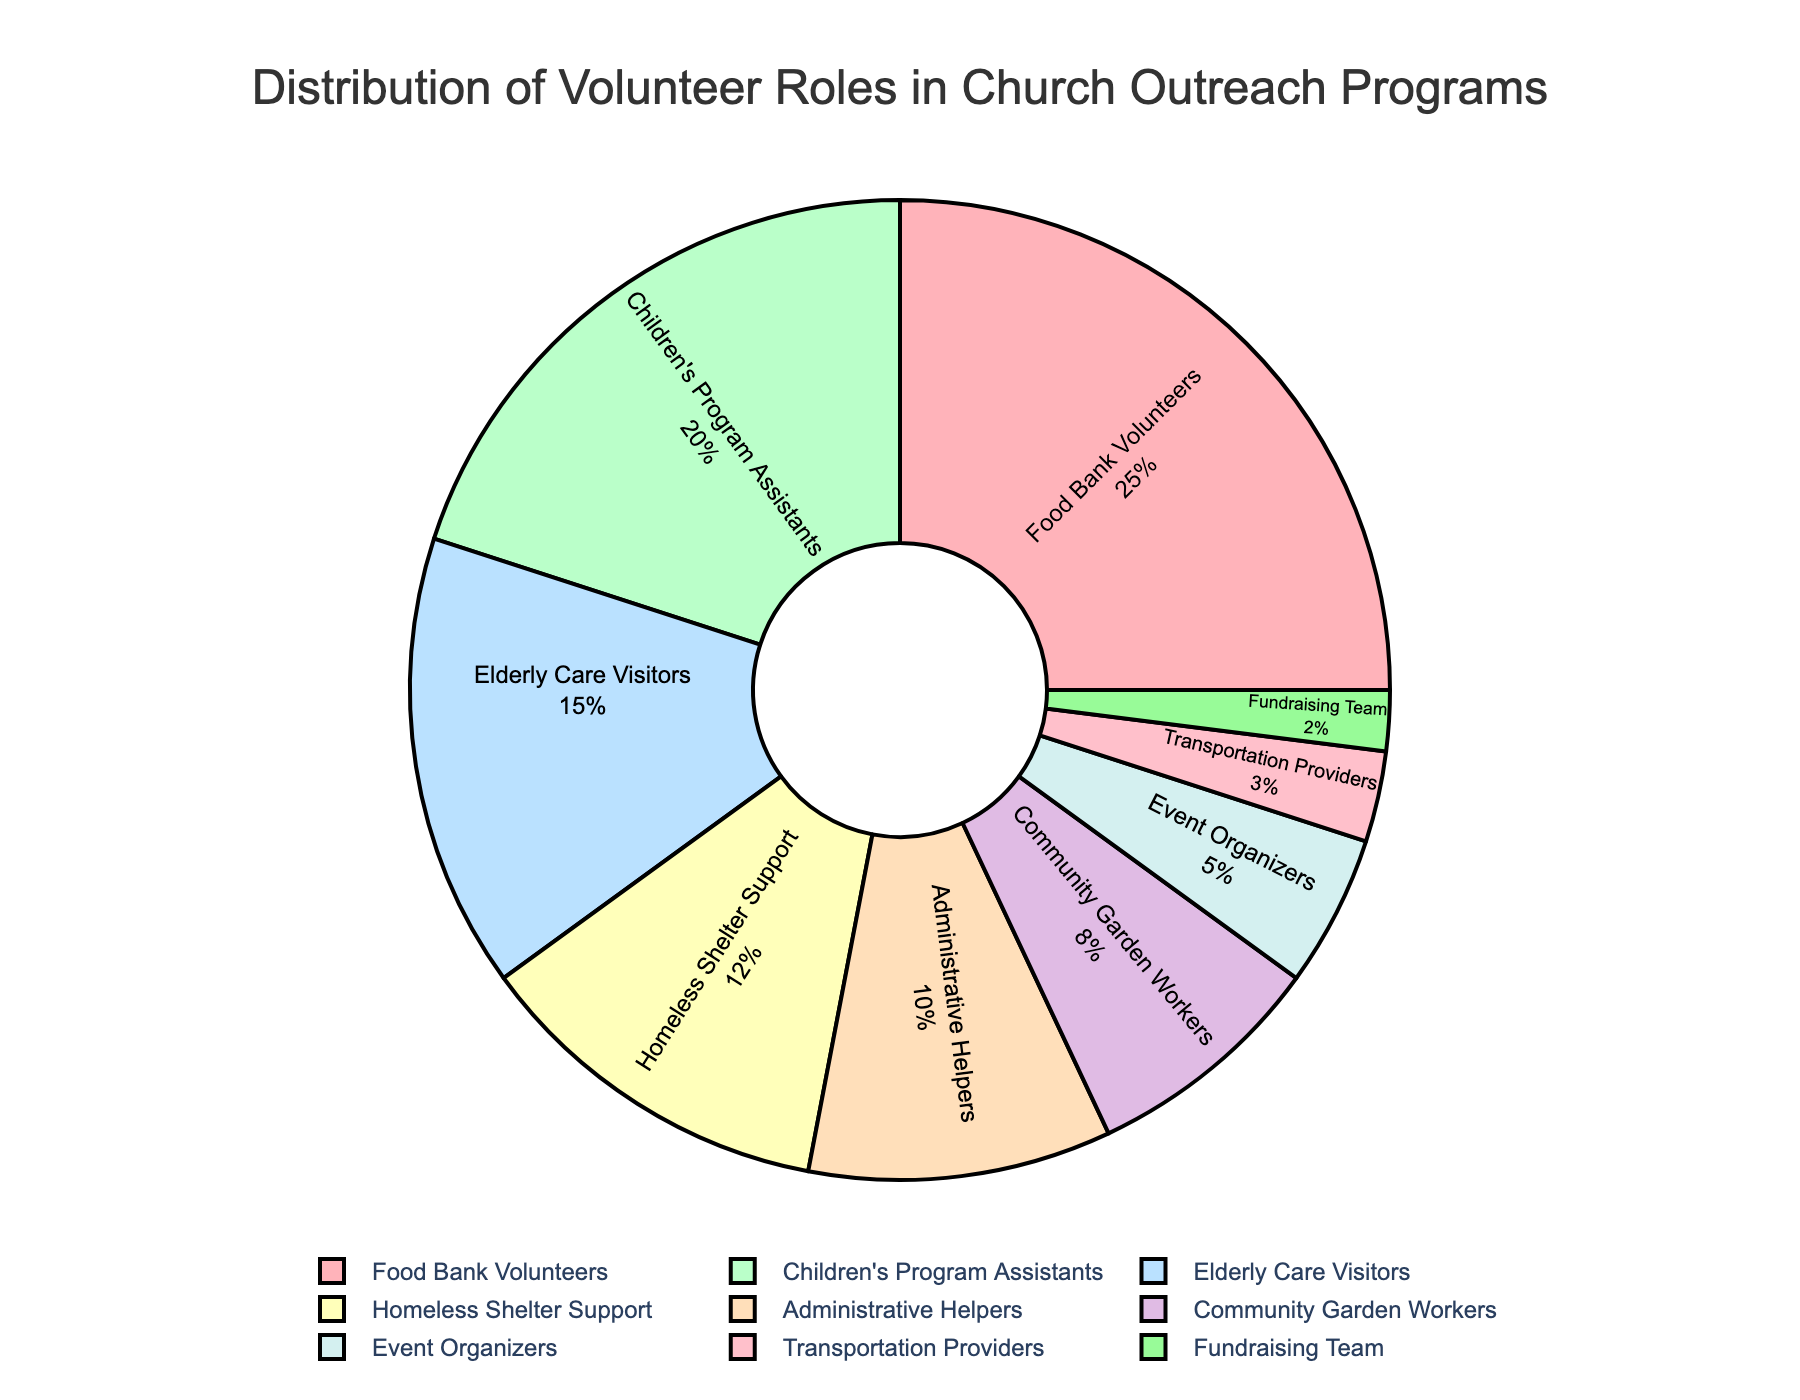What percentage of volunteers are involved in the Children's Program Assistants and Elderly Care Visitors combined? Add the percentages of the Children's Program Assistants (20%) and Elderly Care Visitors (15%). 20% + 15% = 35%
Answer: 35% Which volunteer role has the highest percentage, and what is it? Identify the role with the highest percentage from the chart, which is Food Bank Volunteers at 25%.
Answer: Food Bank Volunteers, 25% Are there more Food Bank Volunteers or Community Garden Workers? By how much? Compare the percentages of Food Bank Volunteers (25%) and Community Garden Workers (8%). Subtract the smaller percentage from the larger one. 25% - 8% = 17%
Answer: Yes, by 17% What is the total percentage of volunteers involved in roles that directly support individual well-being (Food Bank Volunteers, Elderly Care Visitors, Homeless Shelter Support, and Transportation Providers)? Add the percentages of Food Bank Volunteers (25%), Elderly Care Visitors (15%), Homeless Shelter Support (12%), and Transportation Providers (3%). 25% + 15% + 12% + 3% = 55%
Answer: 55% Which three roles have the lowest percentage of volunteers, and what are their percentages? Identify the roles with the lowest percentages: Fundraising Team (2%), Transportation Providers (3%), and Event Organizers (5%).
Answer: Fundraising Team, 2%; Transportation Providers, 3%; Event Organizers, 5% Is the percentage of Administrative Helpers greater than, less than, or equal to the percentage of Community Garden Workers combined with Event Organizers? Compare the percentage of Administrative Helpers (10%) with the sum of the percentages of Community Garden Workers (8%) and Event Organizers (5%). 8% + 5% = 13%, which is greater than 10%.
Answer: Less than What visual difference can you see between the segments representing Food Bank Volunteers and Homeless Shelter Support? Notice the size and colors of the segments. The Food Bank Volunteers segment is larger and has a distinct color compared to the Homeless Shelter Support segment.
Answer: Larger, different color Which role accounts for exactly twice the percentage of the Transportation Providers, and what is that percentage? Find a role whose percentage is twice that of the Transportation Providers (3%). Children's Program Assistants at 20% is not correct. Instead, Administrative Helpers at 10% is correct, since 3% * 2 < 6%
Answer: None 